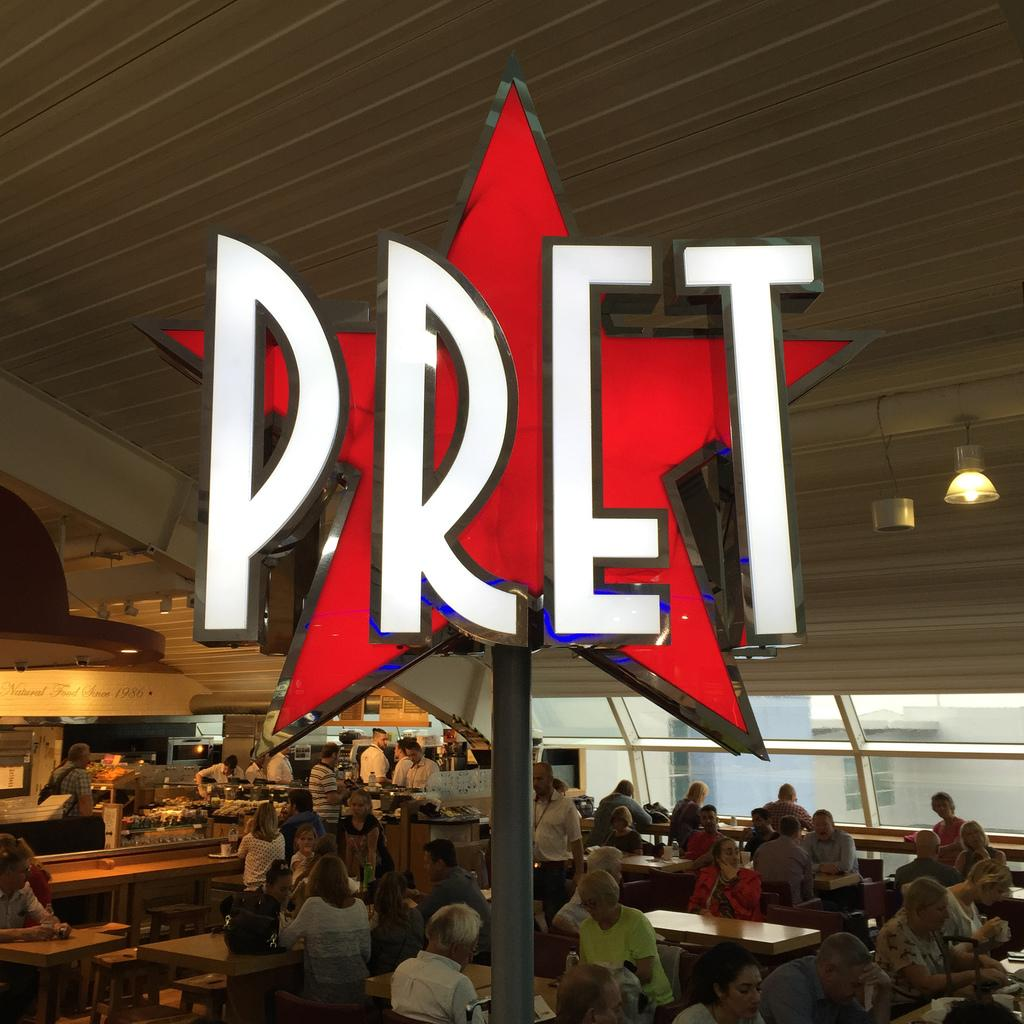What are the people in the image doing? The people in the image are sitting on chairs. Where are the chairs located in relation to the table? The chairs are in front of the table. What shape can be seen in the image? There is a star shape in the image. What word is written within the star shape? The word "pret" is written in white color within the star shape. What type of cable is being used to serve the soup in the image? There is no cable or soup present in the image. What facial expression can be seen on the face of the person sitting on the chair? There is no face visible in the image, as it only shows people sitting on chairs and a star shape with the word "pret" written within it. 